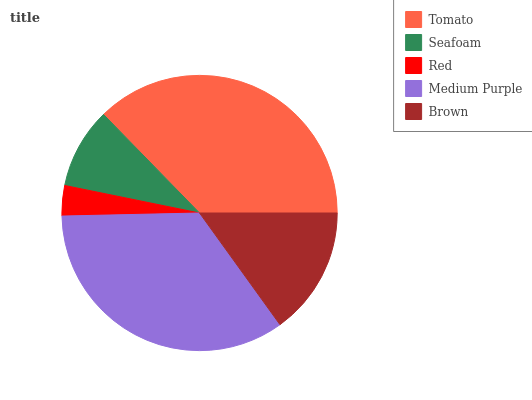Is Red the minimum?
Answer yes or no. Yes. Is Tomato the maximum?
Answer yes or no. Yes. Is Seafoam the minimum?
Answer yes or no. No. Is Seafoam the maximum?
Answer yes or no. No. Is Tomato greater than Seafoam?
Answer yes or no. Yes. Is Seafoam less than Tomato?
Answer yes or no. Yes. Is Seafoam greater than Tomato?
Answer yes or no. No. Is Tomato less than Seafoam?
Answer yes or no. No. Is Brown the high median?
Answer yes or no. Yes. Is Brown the low median?
Answer yes or no. Yes. Is Medium Purple the high median?
Answer yes or no. No. Is Tomato the low median?
Answer yes or no. No. 